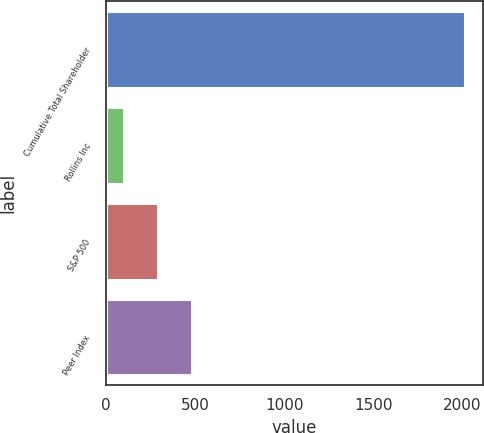Convert chart. <chart><loc_0><loc_0><loc_500><loc_500><bar_chart><fcel>Cumulative Total Shareholder<fcel>Rollins Inc<fcel>S&P 500<fcel>Peer Index<nl><fcel>2012<fcel>101.06<fcel>292.15<fcel>483.24<nl></chart> 